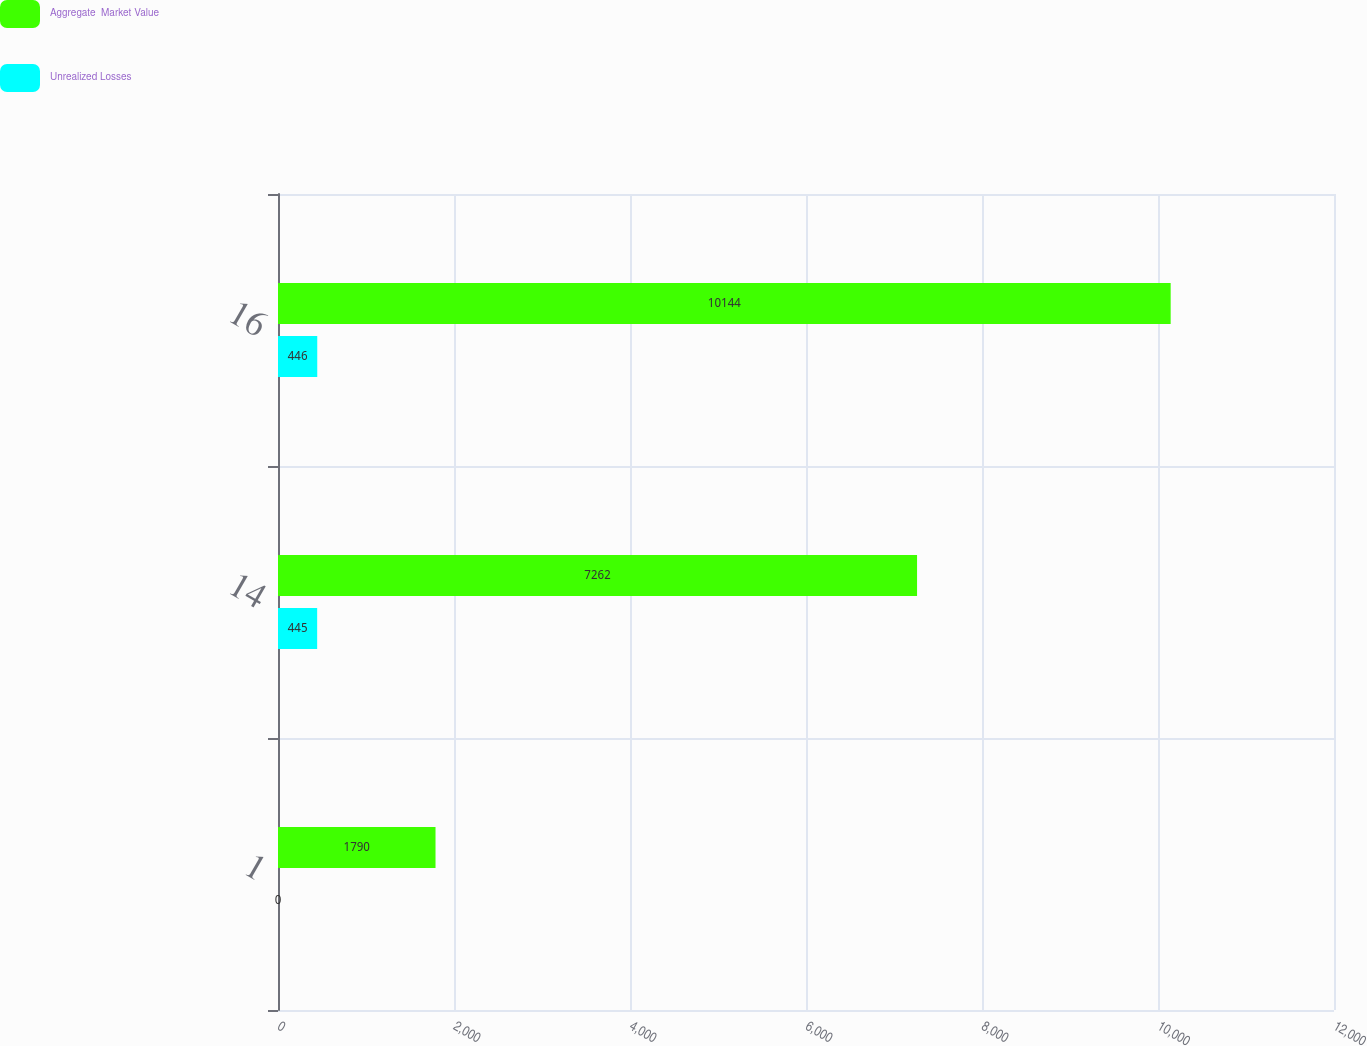<chart> <loc_0><loc_0><loc_500><loc_500><stacked_bar_chart><ecel><fcel>1<fcel>14<fcel>16<nl><fcel>Aggregate  Market Value<fcel>1790<fcel>7262<fcel>10144<nl><fcel>Unrealized Losses<fcel>0<fcel>445<fcel>446<nl></chart> 